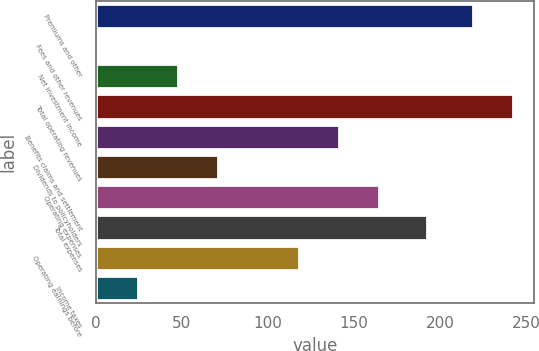<chart> <loc_0><loc_0><loc_500><loc_500><bar_chart><fcel>Premiums and other<fcel>Fees and other revenues<fcel>Net investment income<fcel>Total operating revenues<fcel>Benefits claims and settlement<fcel>Dividends to policyholders<fcel>Operating expenses<fcel>Total expenses<fcel>Operating earnings before<fcel>Income taxes<nl><fcel>218.9<fcel>1.3<fcel>47.86<fcel>242.18<fcel>140.98<fcel>71.14<fcel>164.26<fcel>192<fcel>117.7<fcel>24.58<nl></chart> 